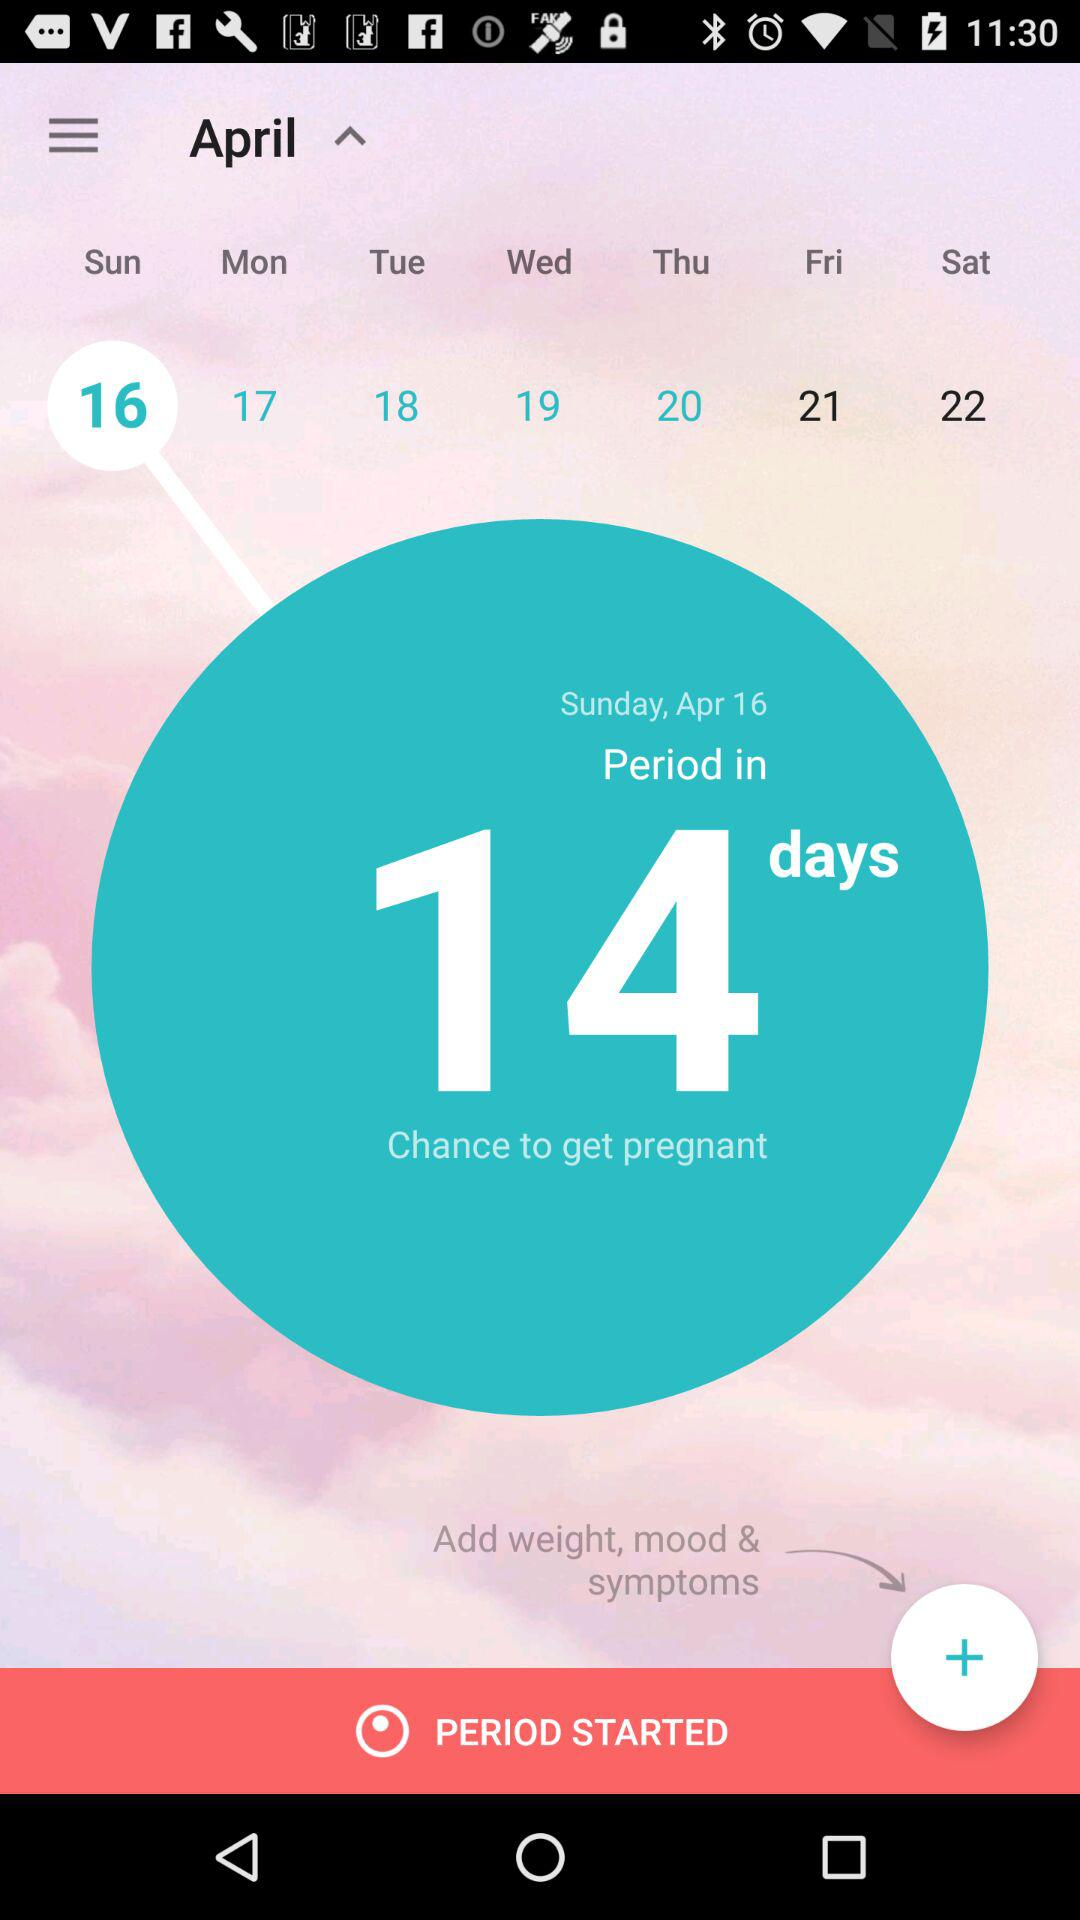How many days are left for the period? There are 14 days left for the period. 